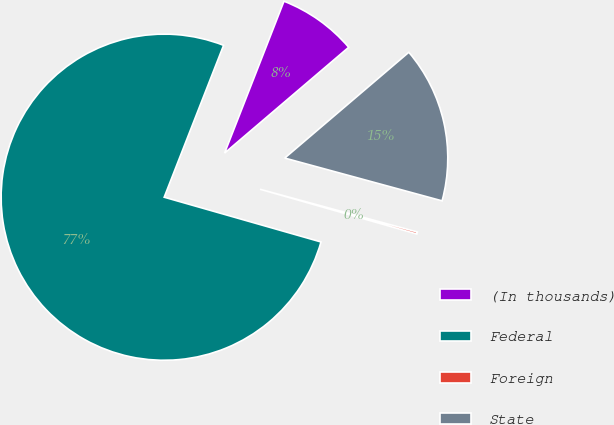Convert chart. <chart><loc_0><loc_0><loc_500><loc_500><pie_chart><fcel>(In thousands)<fcel>Federal<fcel>Foreign<fcel>State<nl><fcel>7.83%<fcel>76.5%<fcel>0.2%<fcel>15.46%<nl></chart> 